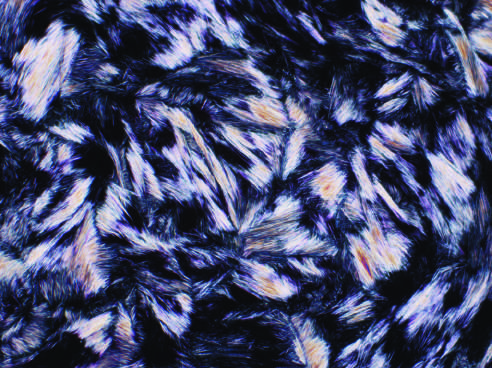what shape are urate crystals?
Answer the question using a single word or phrase. Needle 